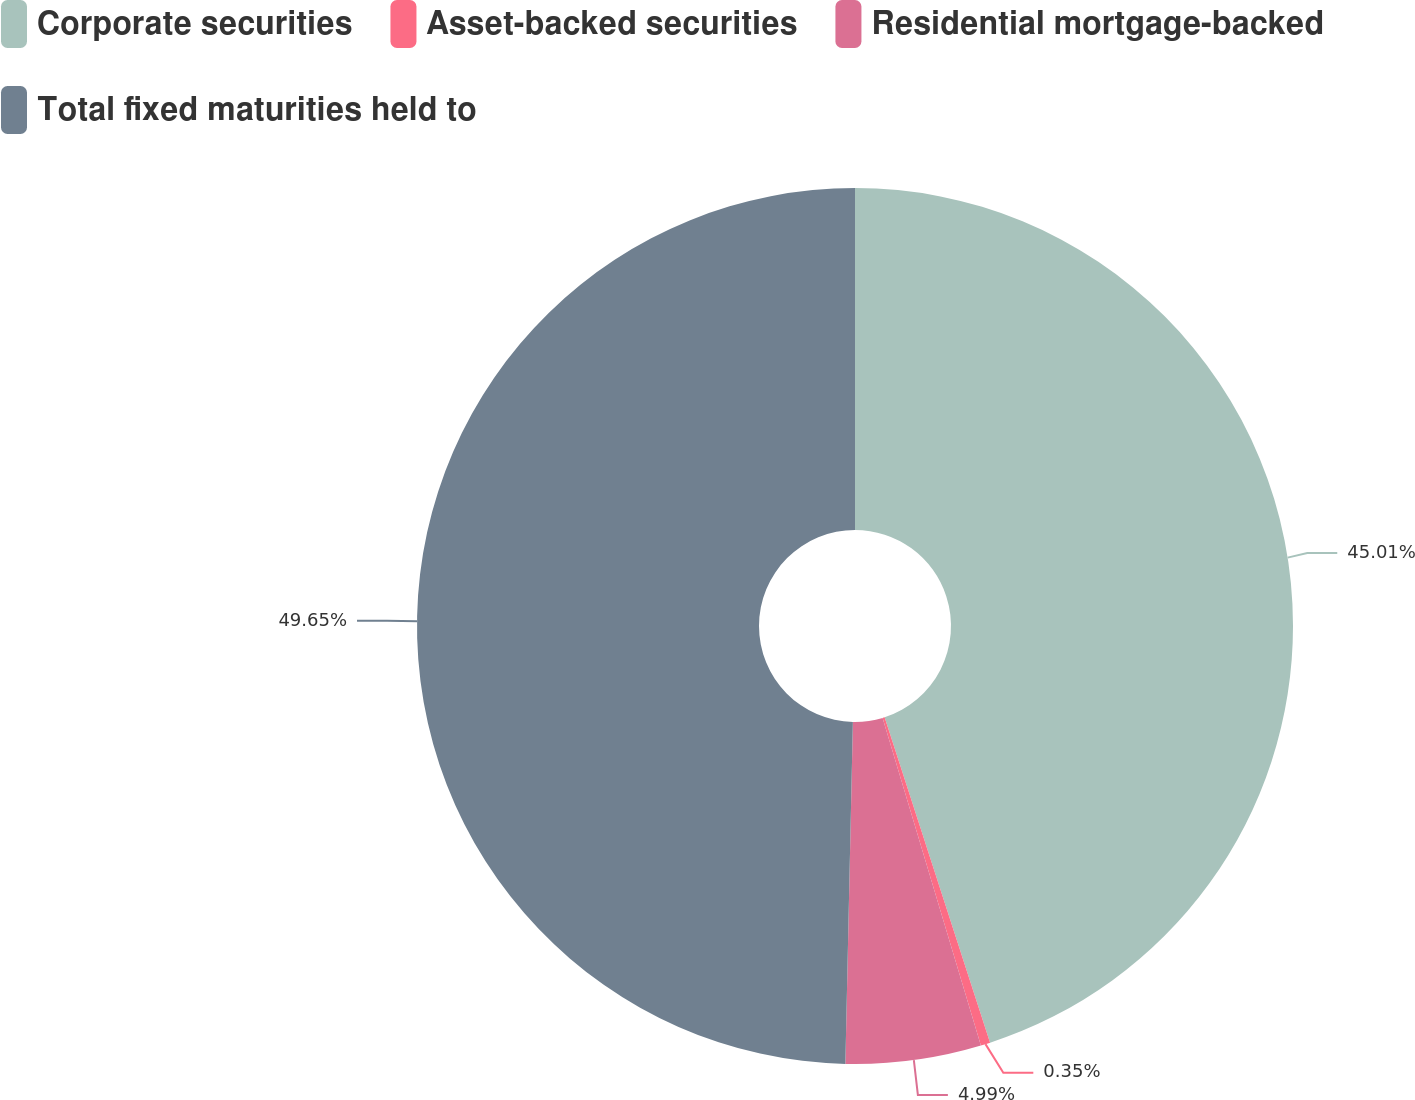Convert chart. <chart><loc_0><loc_0><loc_500><loc_500><pie_chart><fcel>Corporate securities<fcel>Asset-backed securities<fcel>Residential mortgage-backed<fcel>Total fixed maturities held to<nl><fcel>45.01%<fcel>0.35%<fcel>4.99%<fcel>49.65%<nl></chart> 